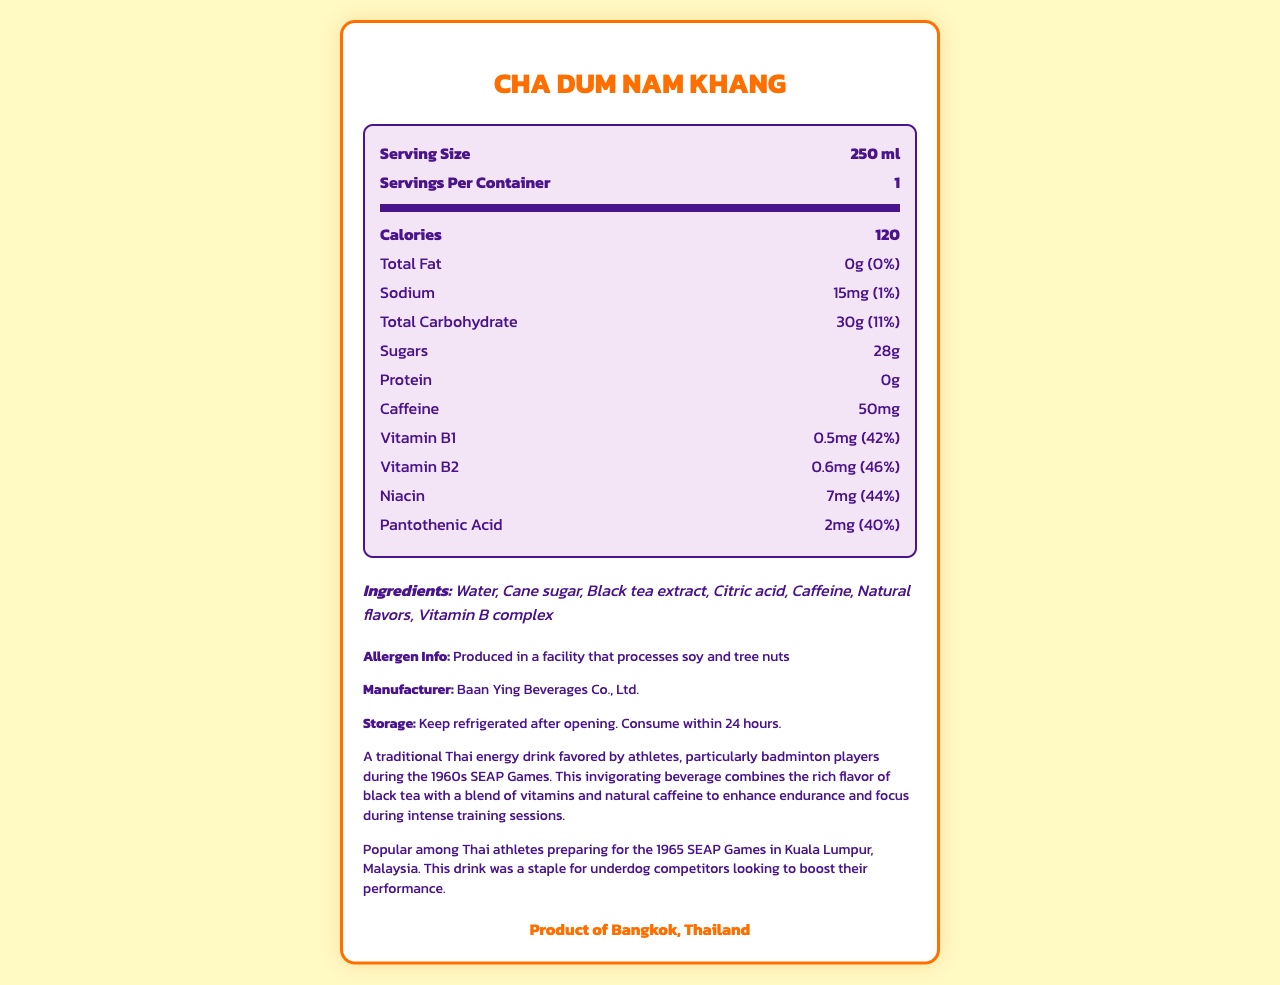what is the serving size? The serving size is listed near the top of the nutrition label under "Serving Size."
Answer: 250 ml how many calories are in one serving of Cha Dum Nam Khang? The number of calories in one serving is stated directly as "Calories: 120."
Answer: 120 what is the amount of total fat per serving? The total fat per serving is located in the nutrition label section, and it is listed as "Total Fat: 0g."
Answer: 0g how much sodium does the drink contain? The sodium content is listed under "Sodium" in the nutrition facts section, showing "15mg."
Answer: 15mg which ingredients are used in the Cha Dum Nam Khang? The ingredients are listed under the "Ingredients" section near the bottom of the document.
Answer: Water, Cane sugar, Black tea extract, Citric acid, Caffeine, Natural flavors, Vitamin B complex how much caffeine does one serving of Cha Dum Nam Khang contain? The amount of caffeine is specified in the nutrition label as "Caffeine: 50mg."
Answer: 50mg what is the daily value percentage of Vitamin B2? A. 40% B. 42% C. 46% D. 44% The daily value percentage of Vitamin B2 can be found in the nutrition label section, which states "Vitamin B2: 0.6mg (46%)."
Answer: C. 46% which nutrient has the highest daily value percentage? A. Vitamin B1 B. Vitamin B2 C. Niacin D. Pantothenic Acid Vitamin B2 has the highest daily value percentage at 46%, which is higher than the other listed vitamins.
Answer: B. Vitamin B2 is Cha Dum Nam Khang produced in Thailand? The product origin is explicitly stated as "Product of Bangkok, Thailand."
Answer: Yes Summarize the main idea of the document. The main idea encompasses the primary details from the entire document, including product description, nutrition facts, ingredients, and historical context.
Answer: "The document provides the nutrition facts, ingredients, and additional information for Cha Dum Nam Khang, a traditional Thai energy drink. This drink, containing 120 calories, high in Vitamin B complex, and 50mg of caffeine, is designed to enhance endurance and focus during training. It is popular among athletes from the 1960s SEAP Games." what is the address of the manufacturer? The document only states that the manufacturer is "Baan Ying Beverages Co., Ltd." without providing an address.
Answer: Not enough information 